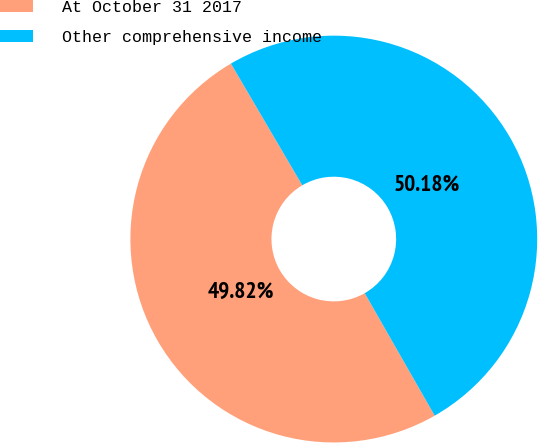Convert chart. <chart><loc_0><loc_0><loc_500><loc_500><pie_chart><fcel>At October 31 2017<fcel>Other comprehensive income<nl><fcel>49.82%<fcel>50.18%<nl></chart> 